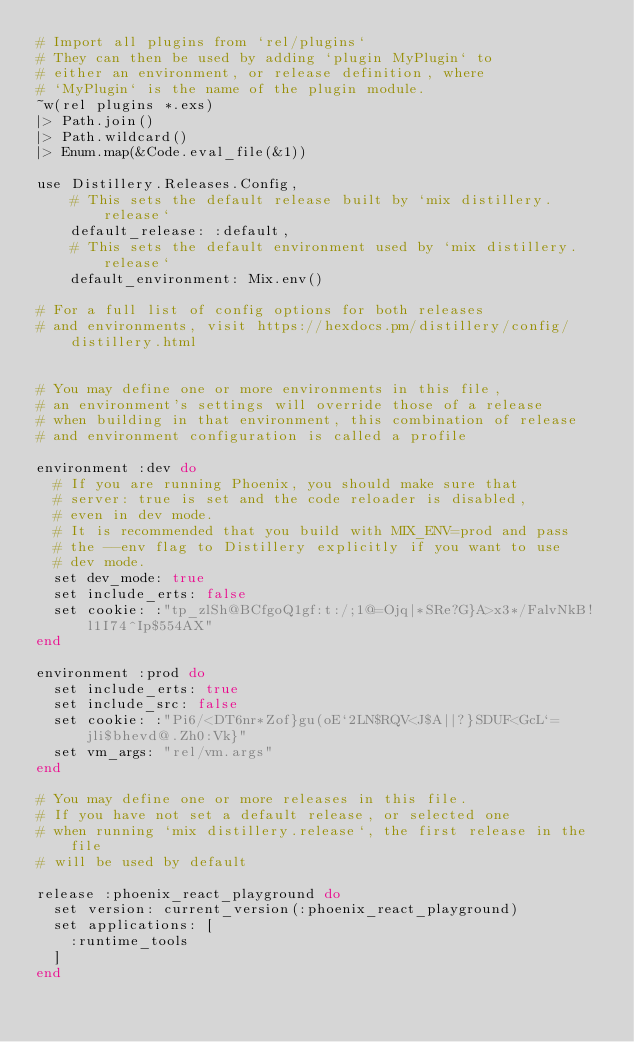Convert code to text. <code><loc_0><loc_0><loc_500><loc_500><_Elixir_># Import all plugins from `rel/plugins`
# They can then be used by adding `plugin MyPlugin` to
# either an environment, or release definition, where
# `MyPlugin` is the name of the plugin module.
~w(rel plugins *.exs)
|> Path.join()
|> Path.wildcard()
|> Enum.map(&Code.eval_file(&1))

use Distillery.Releases.Config,
    # This sets the default release built by `mix distillery.release`
    default_release: :default,
    # This sets the default environment used by `mix distillery.release`
    default_environment: Mix.env()

# For a full list of config options for both releases
# and environments, visit https://hexdocs.pm/distillery/config/distillery.html


# You may define one or more environments in this file,
# an environment's settings will override those of a release
# when building in that environment, this combination of release
# and environment configuration is called a profile

environment :dev do
  # If you are running Phoenix, you should make sure that
  # server: true is set and the code reloader is disabled,
  # even in dev mode.
  # It is recommended that you build with MIX_ENV=prod and pass
  # the --env flag to Distillery explicitly if you want to use
  # dev mode.
  set dev_mode: true
  set include_erts: false
  set cookie: :"tp_zlSh@BCfgoQ1gf:t:/;1@=Ojq|*SRe?G}A>x3*/FalvNkB!l1I74^Ip$554AX"
end

environment :prod do
  set include_erts: true
  set include_src: false
  set cookie: :"Pi6/<DT6nr*Zof}gu(oE`2LN$RQV<J$A||?}SDUF<GcL`=jli$bhevd@.Zh0:Vk}"
  set vm_args: "rel/vm.args"
end

# You may define one or more releases in this file.
# If you have not set a default release, or selected one
# when running `mix distillery.release`, the first release in the file
# will be used by default

release :phoenix_react_playground do
  set version: current_version(:phoenix_react_playground)
  set applications: [
    :runtime_tools
  ]
end

</code> 